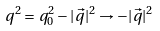Convert formula to latex. <formula><loc_0><loc_0><loc_500><loc_500>q ^ { 2 } = q _ { 0 } ^ { 2 } - | \vec { q } | ^ { 2 } \rightarrow - | \vec { q } | ^ { 2 }</formula> 